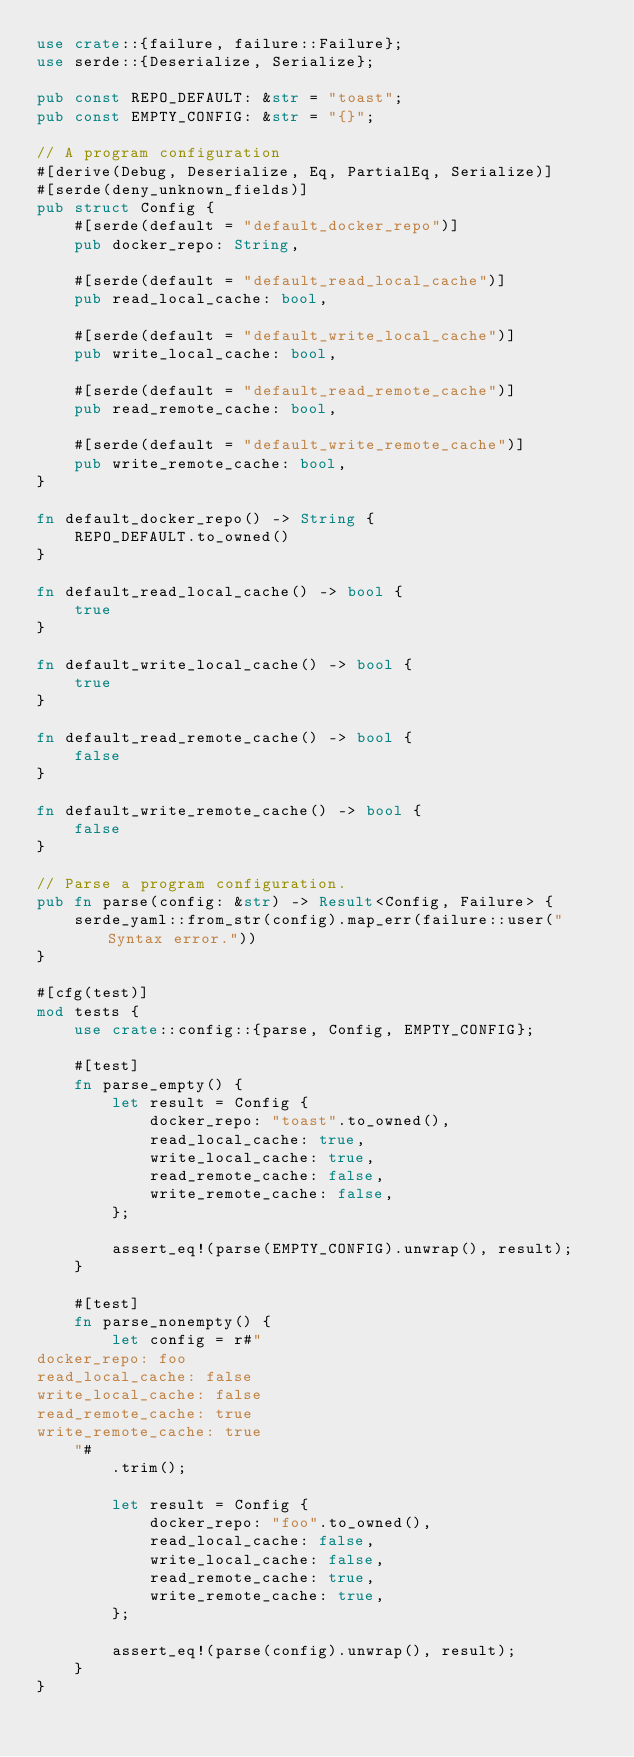Convert code to text. <code><loc_0><loc_0><loc_500><loc_500><_Rust_>use crate::{failure, failure::Failure};
use serde::{Deserialize, Serialize};

pub const REPO_DEFAULT: &str = "toast";
pub const EMPTY_CONFIG: &str = "{}";

// A program configuration
#[derive(Debug, Deserialize, Eq, PartialEq, Serialize)]
#[serde(deny_unknown_fields)]
pub struct Config {
    #[serde(default = "default_docker_repo")]
    pub docker_repo: String,

    #[serde(default = "default_read_local_cache")]
    pub read_local_cache: bool,

    #[serde(default = "default_write_local_cache")]
    pub write_local_cache: bool,

    #[serde(default = "default_read_remote_cache")]
    pub read_remote_cache: bool,

    #[serde(default = "default_write_remote_cache")]
    pub write_remote_cache: bool,
}

fn default_docker_repo() -> String {
    REPO_DEFAULT.to_owned()
}

fn default_read_local_cache() -> bool {
    true
}

fn default_write_local_cache() -> bool {
    true
}

fn default_read_remote_cache() -> bool {
    false
}

fn default_write_remote_cache() -> bool {
    false
}

// Parse a program configuration.
pub fn parse(config: &str) -> Result<Config, Failure> {
    serde_yaml::from_str(config).map_err(failure::user("Syntax error."))
}

#[cfg(test)]
mod tests {
    use crate::config::{parse, Config, EMPTY_CONFIG};

    #[test]
    fn parse_empty() {
        let result = Config {
            docker_repo: "toast".to_owned(),
            read_local_cache: true,
            write_local_cache: true,
            read_remote_cache: false,
            write_remote_cache: false,
        };

        assert_eq!(parse(EMPTY_CONFIG).unwrap(), result);
    }

    #[test]
    fn parse_nonempty() {
        let config = r#"
docker_repo: foo
read_local_cache: false
write_local_cache: false
read_remote_cache: true
write_remote_cache: true
    "#
        .trim();

        let result = Config {
            docker_repo: "foo".to_owned(),
            read_local_cache: false,
            write_local_cache: false,
            read_remote_cache: true,
            write_remote_cache: true,
        };

        assert_eq!(parse(config).unwrap(), result);
    }
}
</code> 